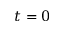Convert formula to latex. <formula><loc_0><loc_0><loc_500><loc_500>t = 0</formula> 